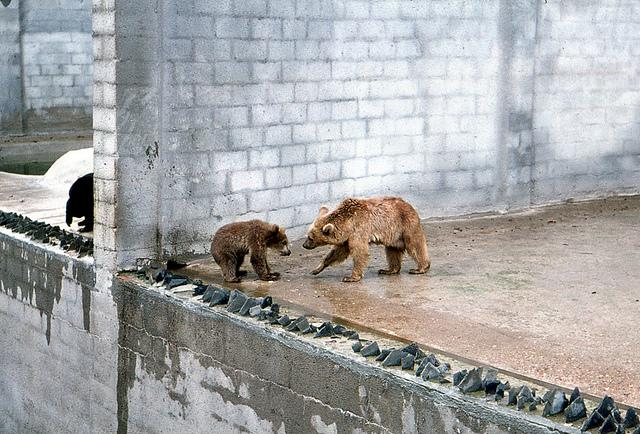What type of bears are in the foreground? Please explain your reasoning. grizzly. The brown and scruffy furred appearance of these bears identifies them as grizzlies. 